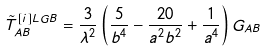<formula> <loc_0><loc_0><loc_500><loc_500>\tilde { T } ^ { \left [ i \right ] L G B } _ { A B } = \frac { 3 } { \lambda ^ { 2 } } \left ( \frac { 5 } { b ^ { 4 } } - \frac { 2 0 } { a ^ { 2 } b ^ { 2 } } + \frac { 1 } { a ^ { 4 } } \right ) G _ { A B }</formula> 